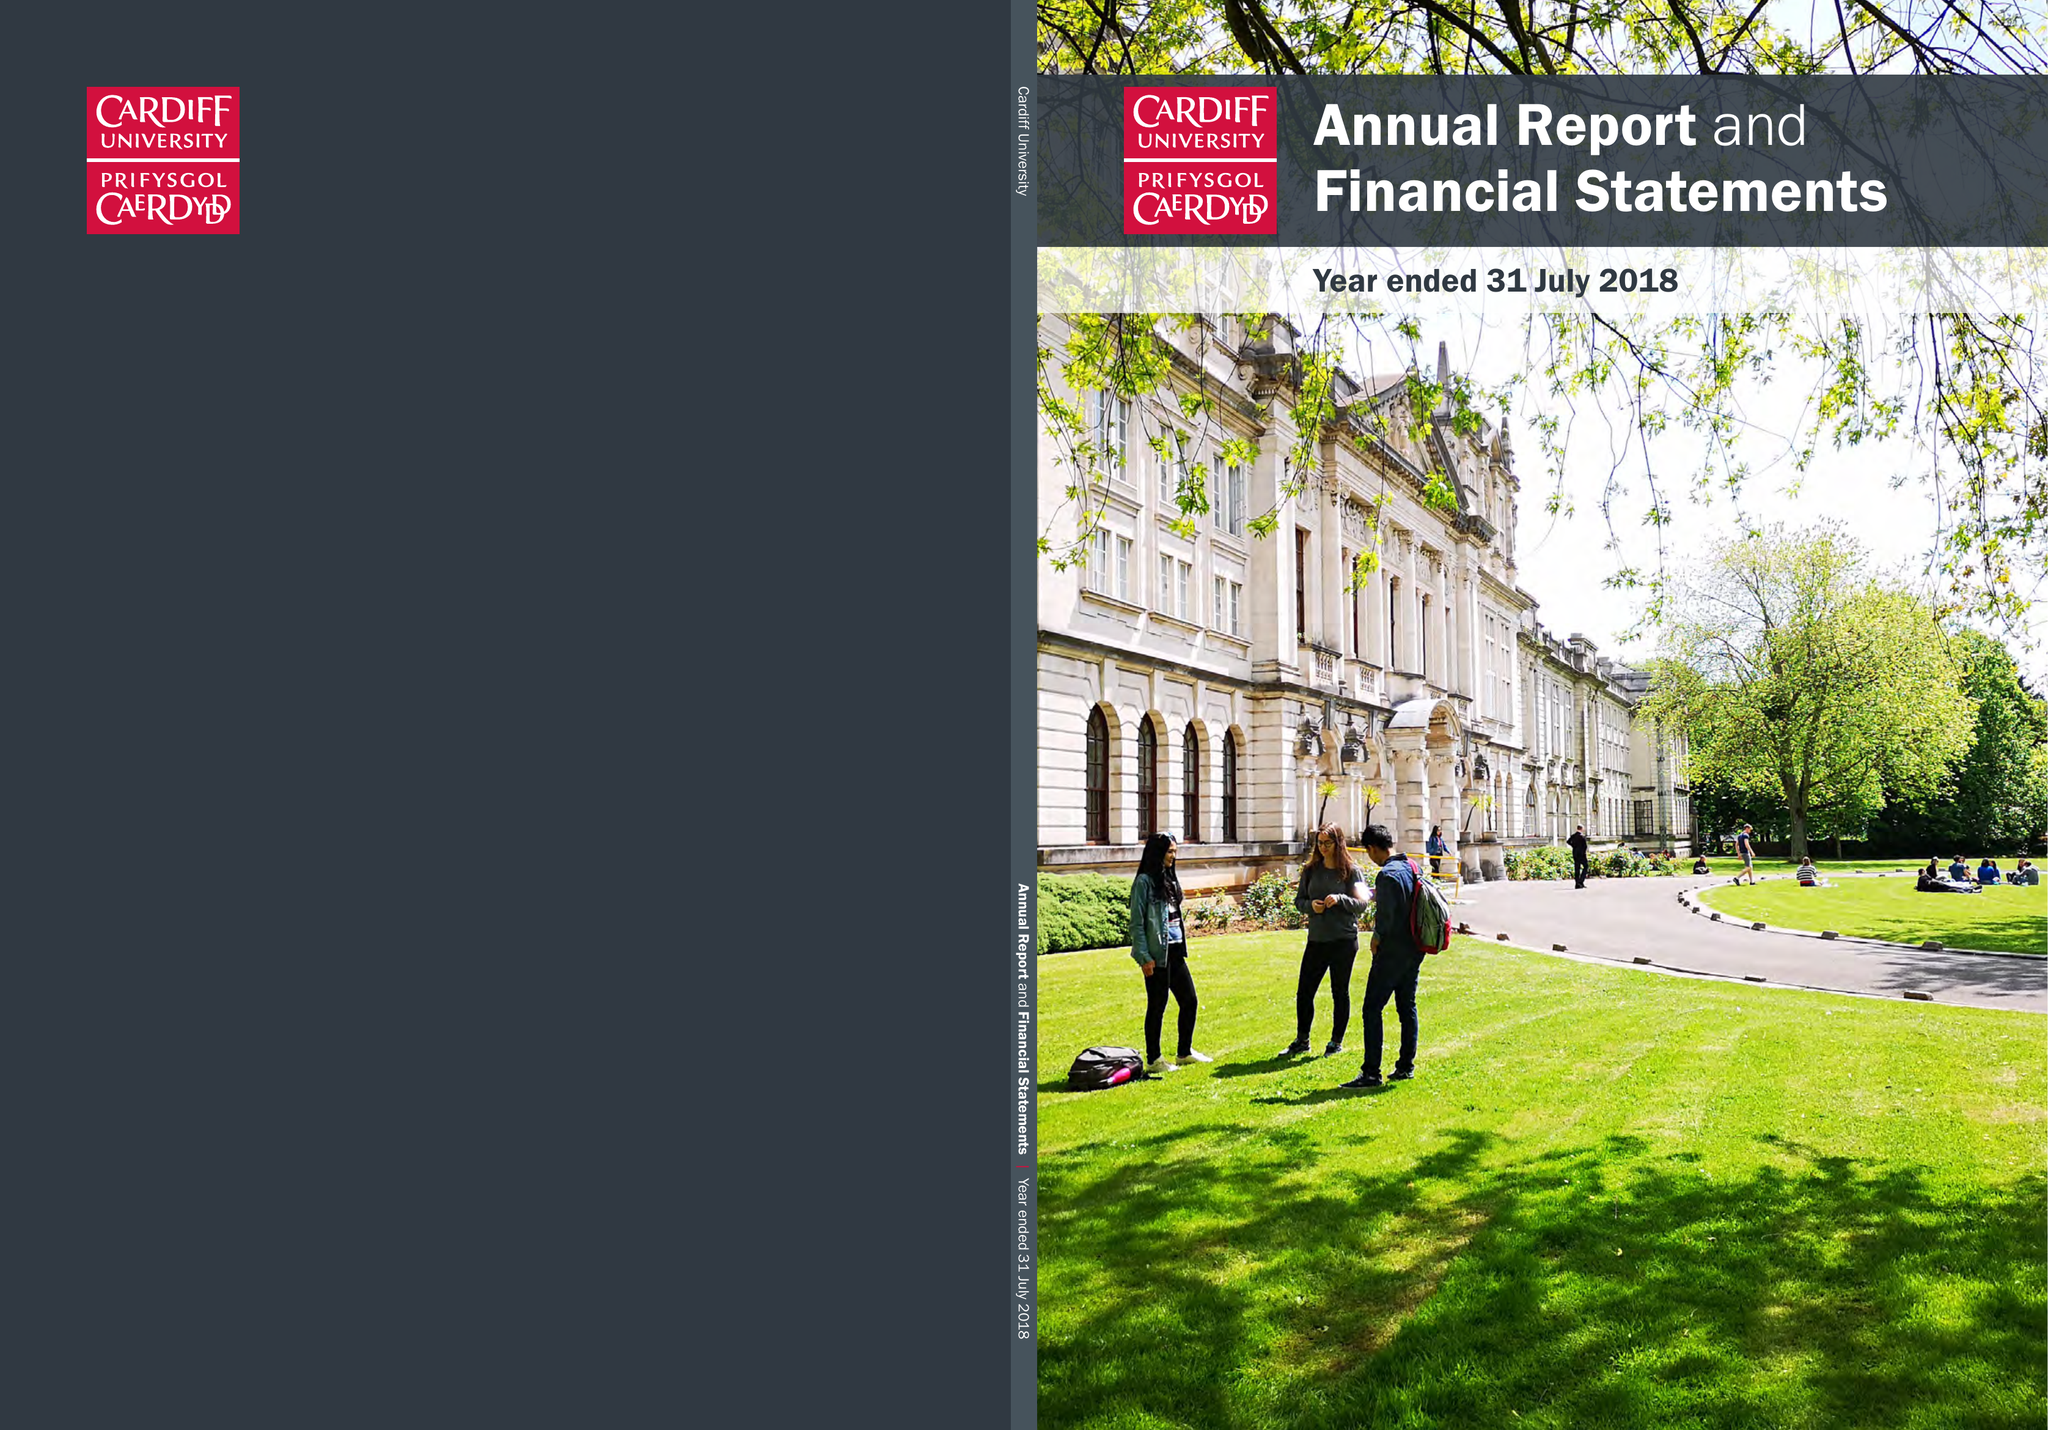What is the value for the address__post_town?
Answer the question using a single word or phrase. CARDIFF 